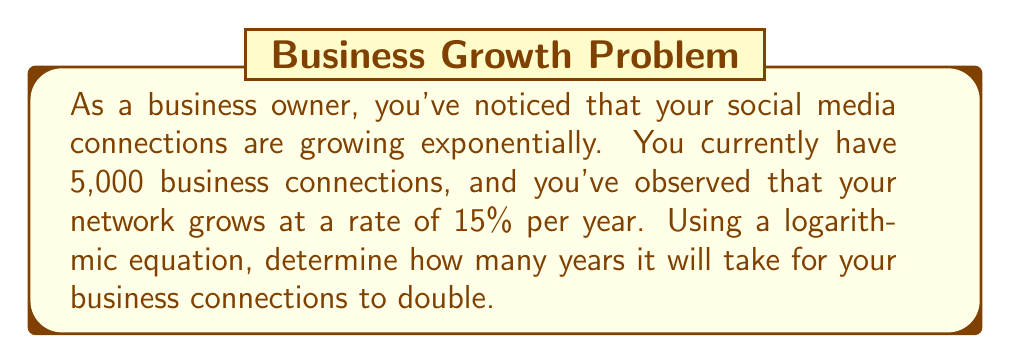Solve this math problem. To solve this problem, we'll use the exponential growth formula and then apply logarithms to isolate the time variable.

1. Let's start with the exponential growth formula:
   $$A = P(1 + r)^t$$
   Where:
   $A$ = Final amount (double the initial connections)
   $P$ = Initial amount (5,000 connections)
   $r$ = Growth rate (15% = 0.15)
   $t$ = Time in years (what we're solving for)

2. We know that we want to double the initial amount, so $A = 2P$:
   $$2P = P(1 + r)^t$$

3. Simplify by dividing both sides by $P$:
   $$2 = (1 + r)^t$$

4. Substitute the known growth rate:
   $$2 = (1 + 0.15)^t$$
   $$2 = (1.15)^t$$

5. To isolate $t$, we need to apply logarithms to both sides. We'll use the natural log (ln) for simplicity:
   $$\ln(2) = \ln((1.15)^t)$$

6. Using the logarithm property $\ln(a^b) = b\ln(a)$, we get:
   $$\ln(2) = t\ln(1.15)$$

7. Now we can solve for $t$ by dividing both sides by $\ln(1.15)$:
   $$t = \frac{\ln(2)}{\ln(1.15)}$$

8. Calculate the result:
   $$t \approx 4.96 \text{ years}$$

Therefore, it will take approximately 4.96 years for your business connections to double.
Answer: $4.96$ years 